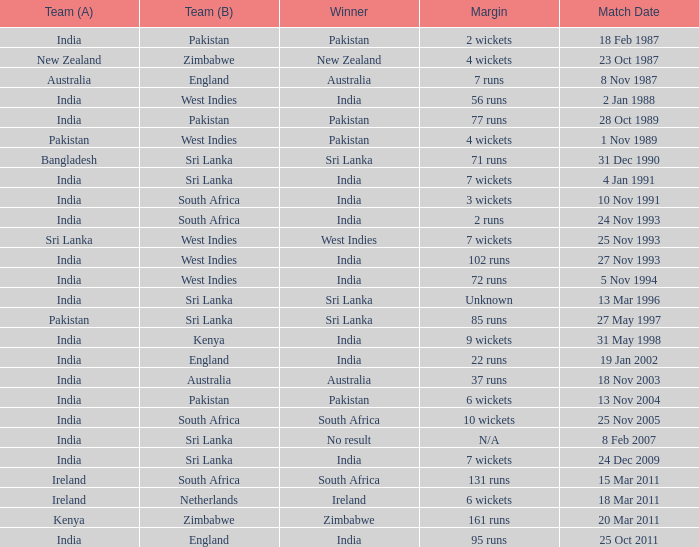How many games were won by a margin of 131 runs? 1.0. 